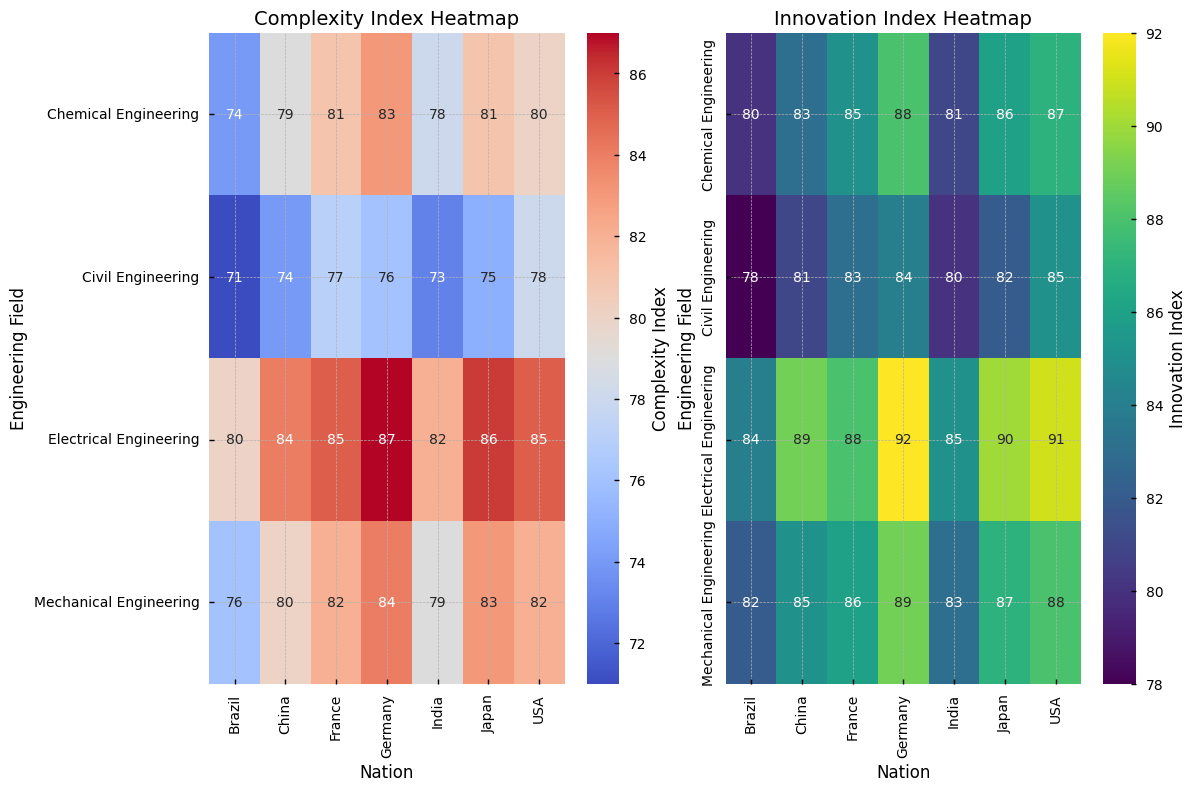What's the highest Complexity Index value? To find the highest Complexity Index value, look for the darkest red cell in the Complexity Index heatmap. In the first heatmap, Electrical Engineering in Germany has the darkest red shade equivalent to the value 87.
Answer: 87 Which nation has the lowest Innovation Index in Civil Engineering? To find this, scan the Innovation Index heatmap for the Civil Engineering row. The lightest-colored cell will indicate the lowest value. Brazil has the lightest color in the Civil Engineering row with the value 78.
Answer: Brazil Compare the Complexity Index of Mechanical Engineering between USA and China. Which nation has a higher value? On the Complexity Index heatmap, locate the row for Mechanical Engineering and compare the values for USA and China. The USA has 82, and China has 80. Therefore, the USA has a higher value.
Answer: USA Which engineering field has the most uniform Innovation Index across all nations? To determine uniformity, look for the field with the least color variation in the Innovation Index heatmap. Mechanical Engineering has the least variation, with most values lying close to each other (82 to 89).
Answer: Mechanical Engineering What is the average Complexity Index for Electrical Engineering across all nations? To find this average, sum the Complexity Index values for Electrical Engineering from all nations and divide by the number of nations: (85 + 87 + 86 + 82 + 84 + 85) / 6. The calculation results in an average Complexity Index: 509 / 6 = 84.83.
Answer: 84.83 Which field shows the largest difference between the Complexity Index and Innovation Index in Germany? First, locate all the values for Germany in both heatmaps. Then calculate the differences for each field. Civil Engineering (84 - 76 = 8), Mechanical Engineering (89 - 84 = 5), Electrical Engineering (92 - 87 = 5), Chemical Engineering (88 - 83 = 5). Civil Engineering has the largest difference of 8.
Answer: Civil Engineering Describe the overall trend for Innovation Index in Chemical Engineering across nations. By examining the Chemical Engineering row in the Innovation Index heatmap, note that values range from 80 to 88. The colors shift from light green (Brazil, India) to darker green and bluish shades as we move to developed nations like Germany, USA, and Japan. The trend indicates higher Innovation Index in more developed nations.
Answer: Higher in developed nations How does the Complexity Index of Civil Engineering in India compare to that in Brazil? Locate the row for Civil Engineering in the Complexity Index heatmap. India has a value of 73, and Brazil has 71; thus, India has a slightly higher Complexity Index than Brazil.
Answer: India 